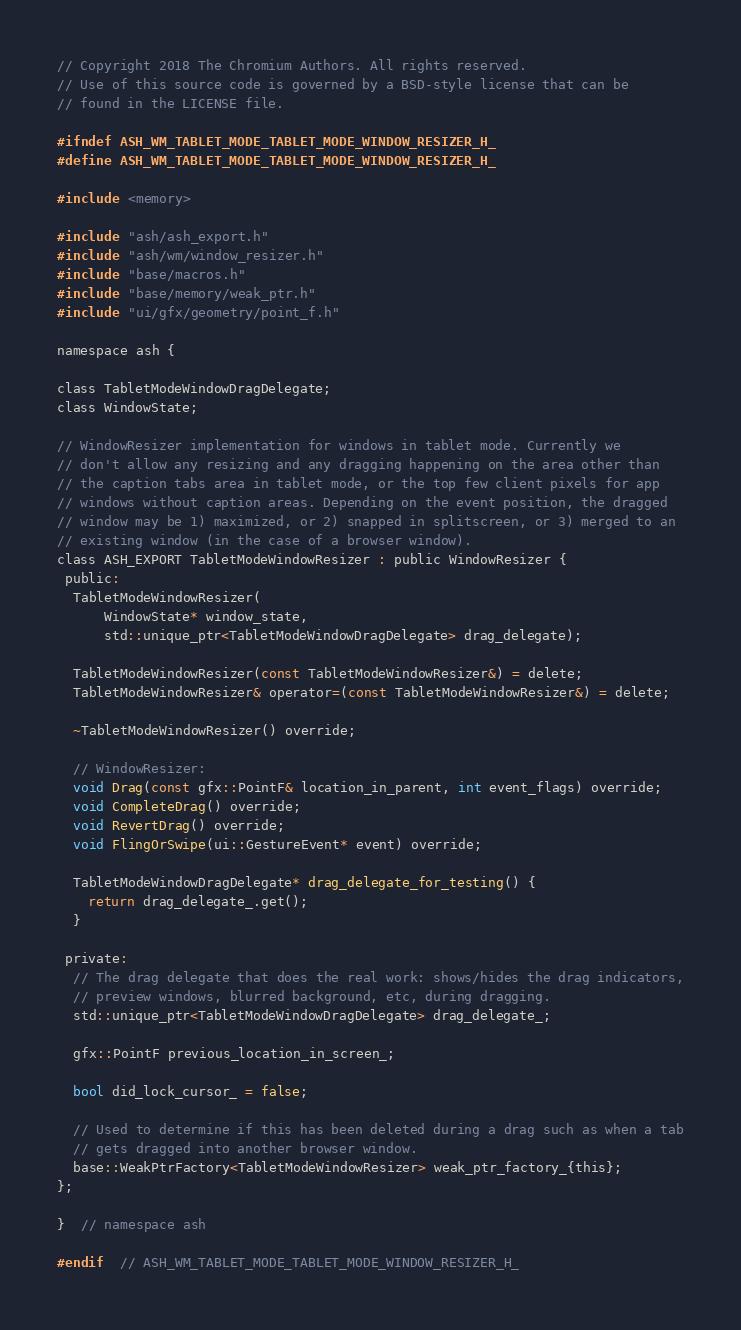Convert code to text. <code><loc_0><loc_0><loc_500><loc_500><_C_>// Copyright 2018 The Chromium Authors. All rights reserved.
// Use of this source code is governed by a BSD-style license that can be
// found in the LICENSE file.

#ifndef ASH_WM_TABLET_MODE_TABLET_MODE_WINDOW_RESIZER_H_
#define ASH_WM_TABLET_MODE_TABLET_MODE_WINDOW_RESIZER_H_

#include <memory>

#include "ash/ash_export.h"
#include "ash/wm/window_resizer.h"
#include "base/macros.h"
#include "base/memory/weak_ptr.h"
#include "ui/gfx/geometry/point_f.h"

namespace ash {

class TabletModeWindowDragDelegate;
class WindowState;

// WindowResizer implementation for windows in tablet mode. Currently we
// don't allow any resizing and any dragging happening on the area other than
// the caption tabs area in tablet mode, or the top few client pixels for app
// windows without caption areas. Depending on the event position, the dragged
// window may be 1) maximized, or 2) snapped in splitscreen, or 3) merged to an
// existing window (in the case of a browser window).
class ASH_EXPORT TabletModeWindowResizer : public WindowResizer {
 public:
  TabletModeWindowResizer(
      WindowState* window_state,
      std::unique_ptr<TabletModeWindowDragDelegate> drag_delegate);

  TabletModeWindowResizer(const TabletModeWindowResizer&) = delete;
  TabletModeWindowResizer& operator=(const TabletModeWindowResizer&) = delete;

  ~TabletModeWindowResizer() override;

  // WindowResizer:
  void Drag(const gfx::PointF& location_in_parent, int event_flags) override;
  void CompleteDrag() override;
  void RevertDrag() override;
  void FlingOrSwipe(ui::GestureEvent* event) override;

  TabletModeWindowDragDelegate* drag_delegate_for_testing() {
    return drag_delegate_.get();
  }

 private:
  // The drag delegate that does the real work: shows/hides the drag indicators,
  // preview windows, blurred background, etc, during dragging.
  std::unique_ptr<TabletModeWindowDragDelegate> drag_delegate_;

  gfx::PointF previous_location_in_screen_;

  bool did_lock_cursor_ = false;

  // Used to determine if this has been deleted during a drag such as when a tab
  // gets dragged into another browser window.
  base::WeakPtrFactory<TabletModeWindowResizer> weak_ptr_factory_{this};
};

}  // namespace ash

#endif  // ASH_WM_TABLET_MODE_TABLET_MODE_WINDOW_RESIZER_H_
</code> 